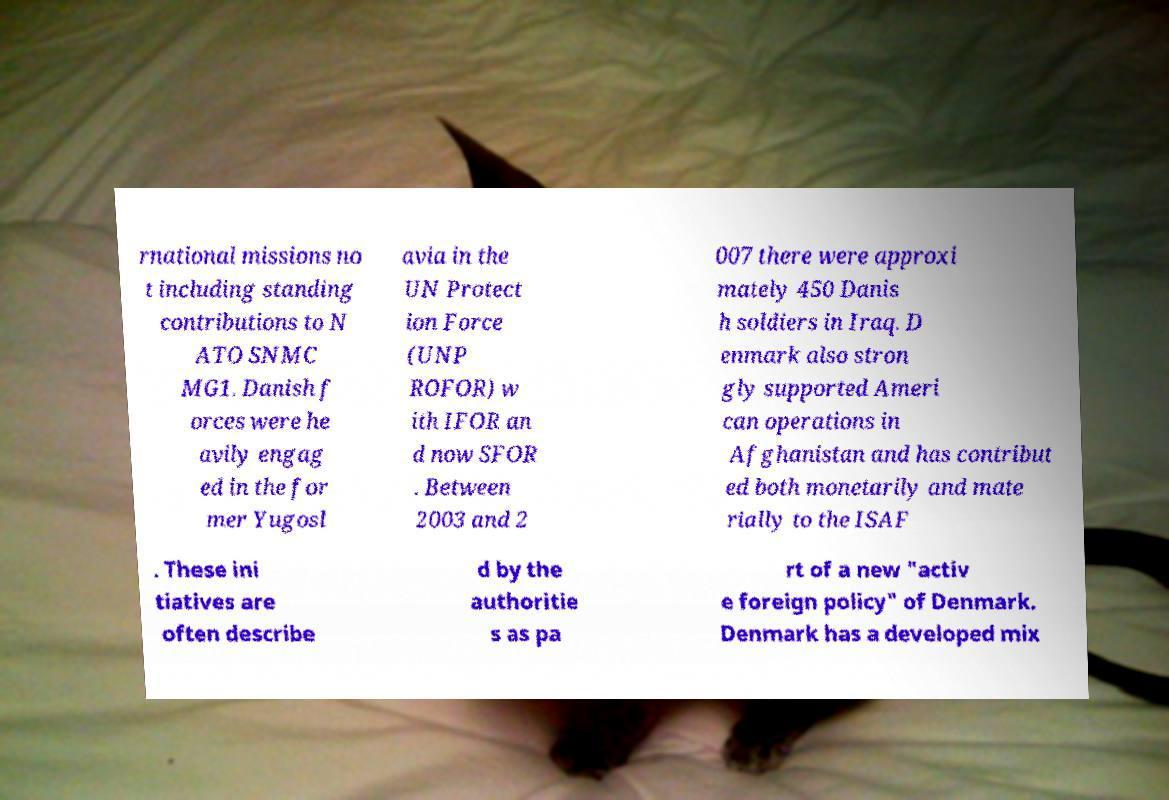Please identify and transcribe the text found in this image. rnational missions no t including standing contributions to N ATO SNMC MG1. Danish f orces were he avily engag ed in the for mer Yugosl avia in the UN Protect ion Force (UNP ROFOR) w ith IFOR an d now SFOR . Between 2003 and 2 007 there were approxi mately 450 Danis h soldiers in Iraq. D enmark also stron gly supported Ameri can operations in Afghanistan and has contribut ed both monetarily and mate rially to the ISAF . These ini tiatives are often describe d by the authoritie s as pa rt of a new "activ e foreign policy" of Denmark. Denmark has a developed mix 